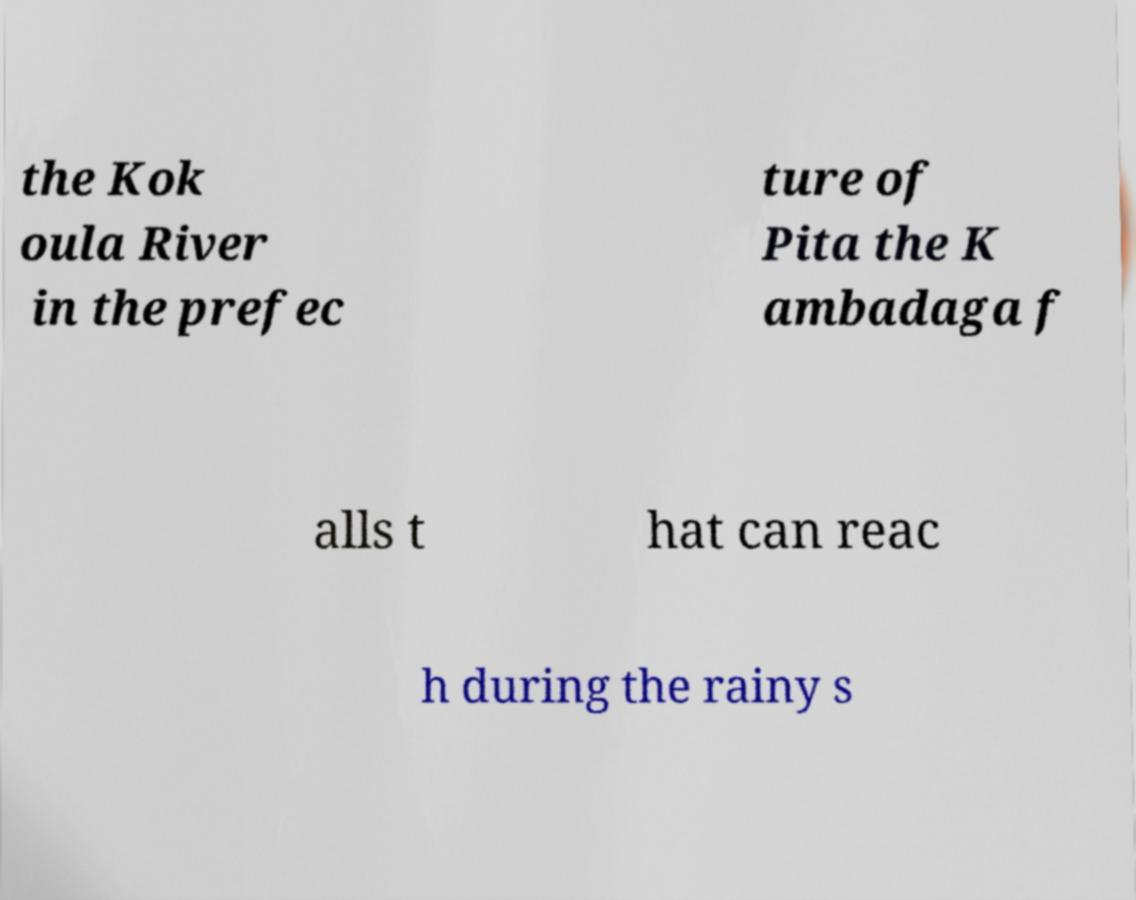What messages or text are displayed in this image? I need them in a readable, typed format. the Kok oula River in the prefec ture of Pita the K ambadaga f alls t hat can reac h during the rainy s 